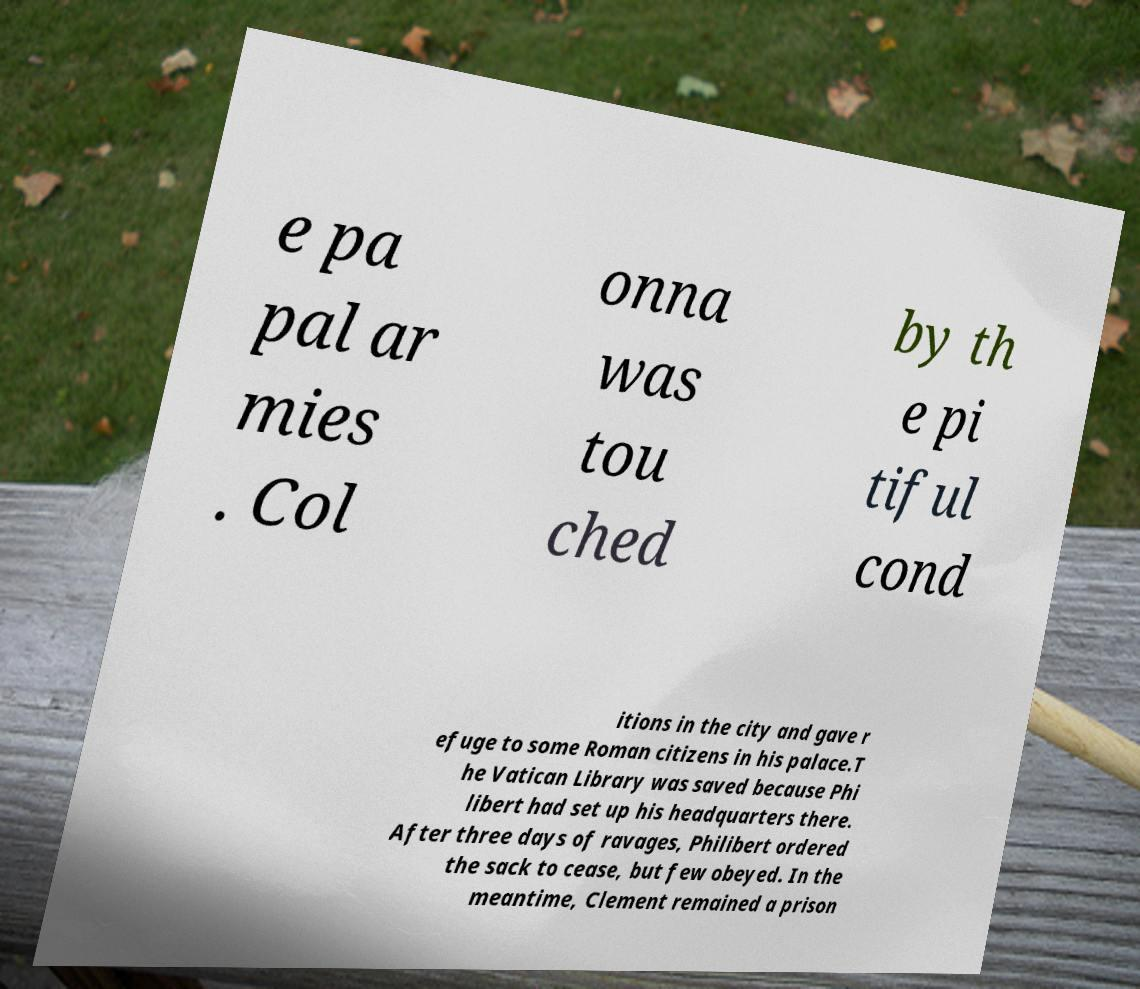I need the written content from this picture converted into text. Can you do that? e pa pal ar mies . Col onna was tou ched by th e pi tiful cond itions in the city and gave r efuge to some Roman citizens in his palace.T he Vatican Library was saved because Phi libert had set up his headquarters there. After three days of ravages, Philibert ordered the sack to cease, but few obeyed. In the meantime, Clement remained a prison 